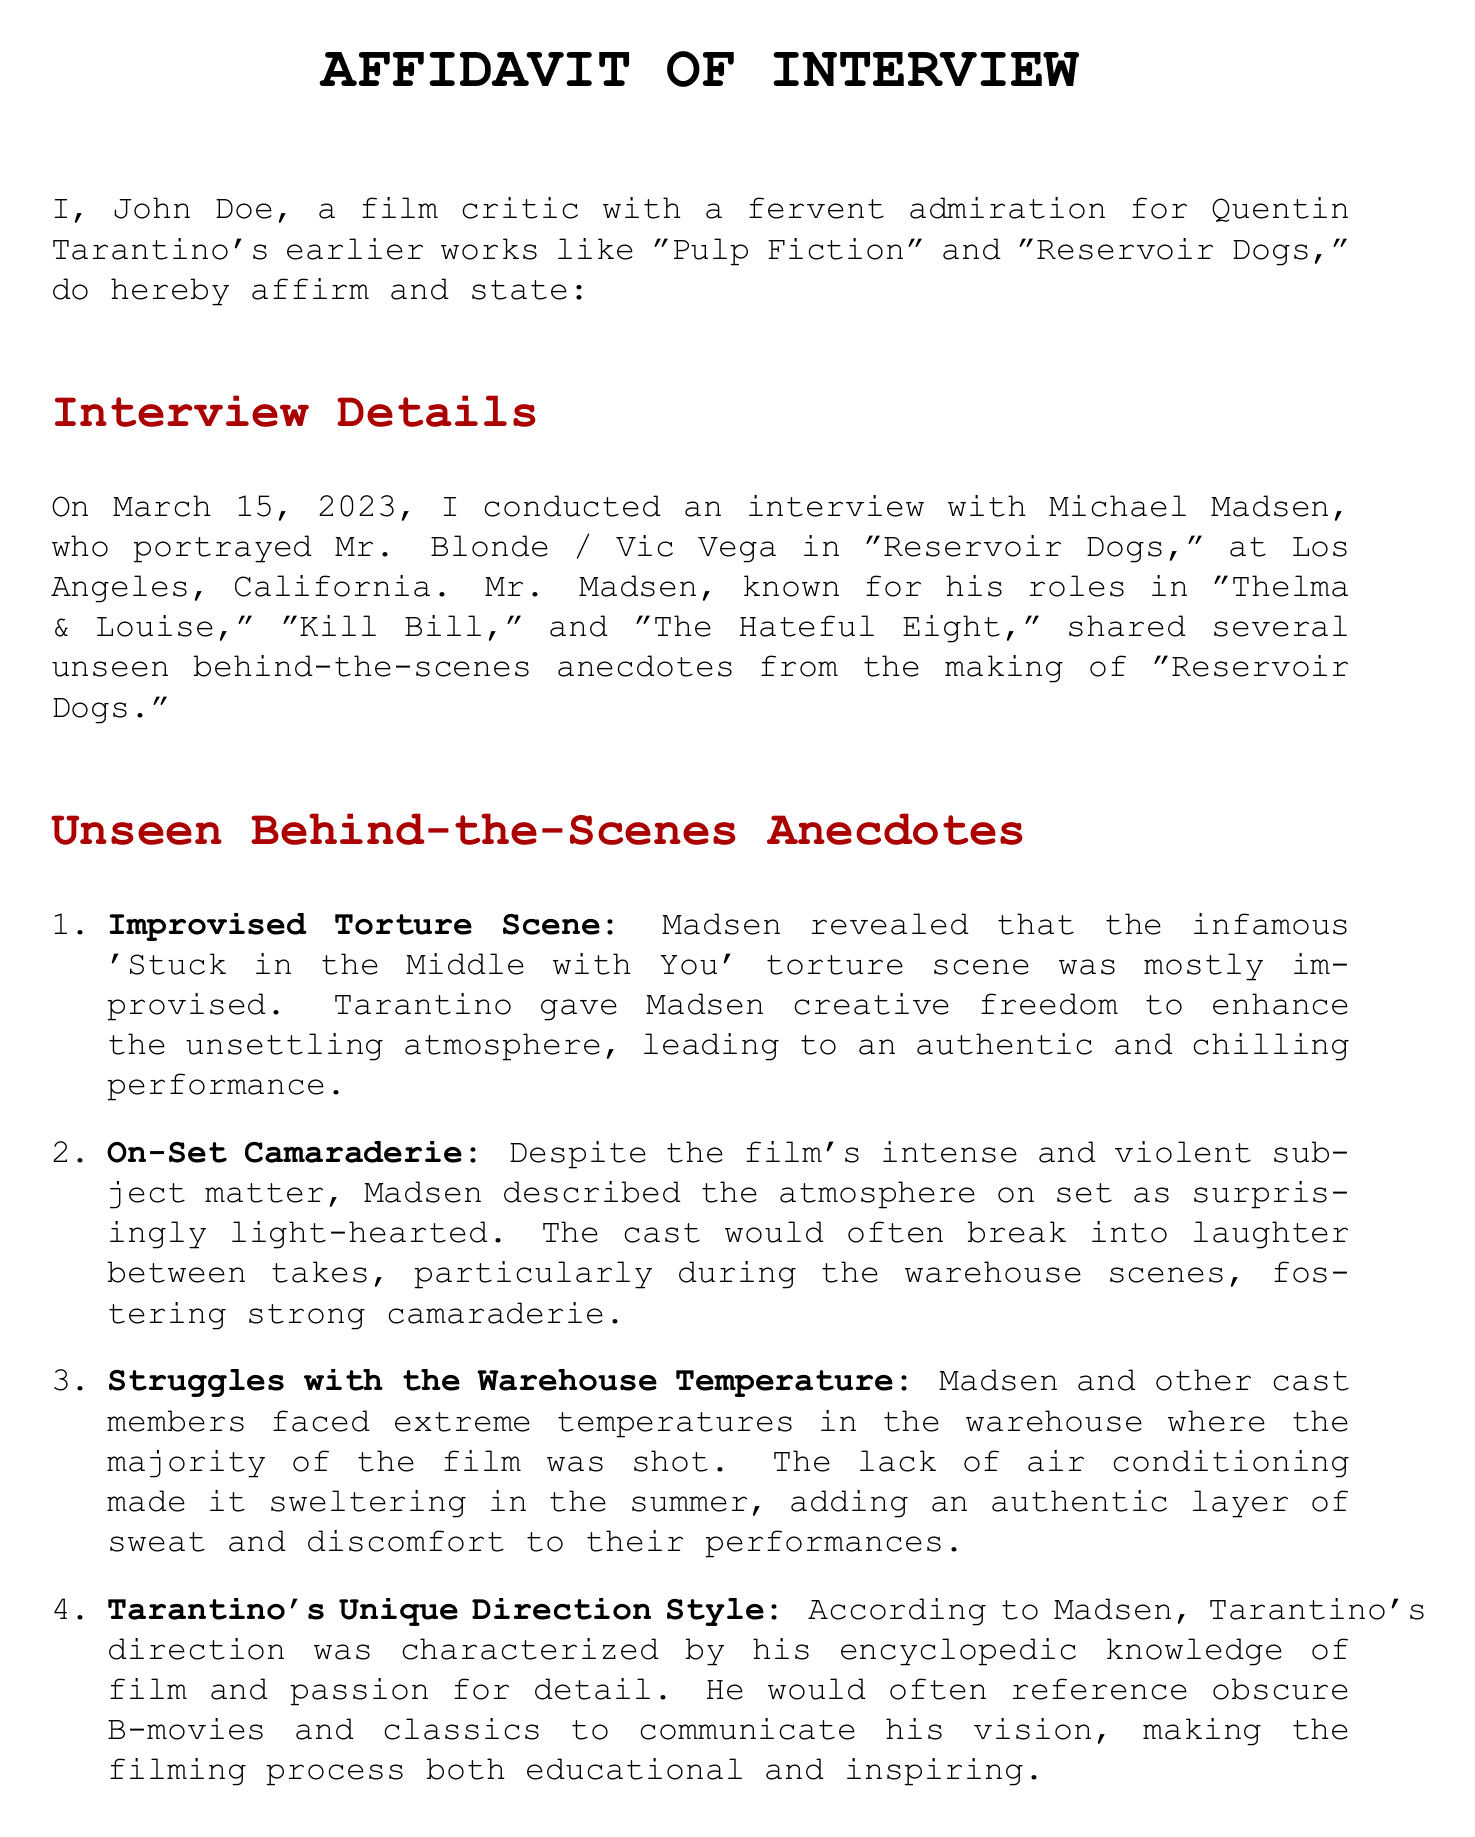What is the name of the interviewee? The interviewee is Michael Madsen, who portrayed a character in "Reservoir Dogs."
Answer: Michael Madsen When was the interview conducted? The interview was conducted on March 15, 2023.
Answer: March 15, 2023 What character did Michael Madsen portray in "Reservoir Dogs"? He portrayed Mr. Blonde / Vic Vega in the film.
Answer: Mr. Blonde / Vic Vega Which song was playing during the improvised torture scene? The song played during this scene was 'Stuck in the Middle with You.'
Answer: 'Stuck in the Middle with You' What aspect of Tarantino's direction was highlighted by Madsen? Madsen highlighted Tarantino's encyclopedic knowledge of film and passion for detail.
Answer: Encyclopedic knowledge of film How did the cast generally feel on set despite the film's violent subject matter? The atmosphere on set was described as surprisingly light-hearted.
Answer: Surprisingly light-hearted What issue did cast members face while filming in the warehouse? They faced extreme temperatures due to the lack of air conditioning.
Answer: Extreme temperatures What type of document is this? This document is an affidavit documenting an interview.
Answer: Affidavit 